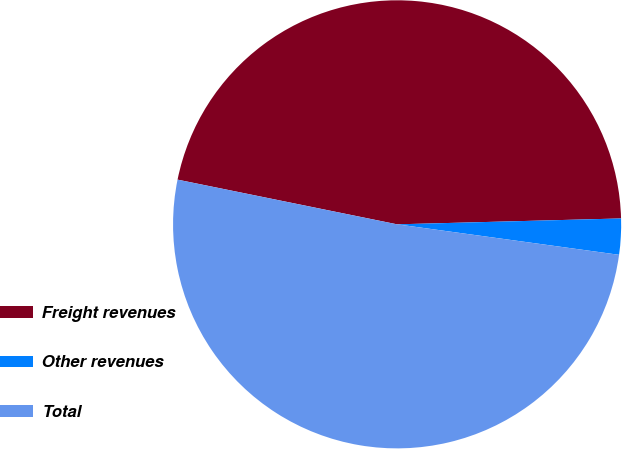<chart> <loc_0><loc_0><loc_500><loc_500><pie_chart><fcel>Freight revenues<fcel>Other revenues<fcel>Total<nl><fcel>46.39%<fcel>2.59%<fcel>51.03%<nl></chart> 